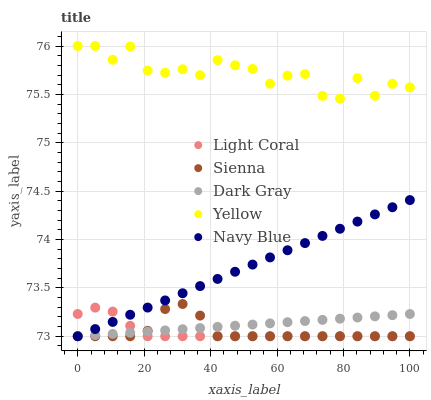Does Light Coral have the minimum area under the curve?
Answer yes or no. Yes. Does Yellow have the maximum area under the curve?
Answer yes or no. Yes. Does Sienna have the minimum area under the curve?
Answer yes or no. No. Does Sienna have the maximum area under the curve?
Answer yes or no. No. Is Navy Blue the smoothest?
Answer yes or no. Yes. Is Yellow the roughest?
Answer yes or no. Yes. Is Sienna the smoothest?
Answer yes or no. No. Is Sienna the roughest?
Answer yes or no. No. Does Light Coral have the lowest value?
Answer yes or no. Yes. Does Yellow have the lowest value?
Answer yes or no. No. Does Yellow have the highest value?
Answer yes or no. Yes. Does Sienna have the highest value?
Answer yes or no. No. Is Navy Blue less than Yellow?
Answer yes or no. Yes. Is Yellow greater than Light Coral?
Answer yes or no. Yes. Does Navy Blue intersect Dark Gray?
Answer yes or no. Yes. Is Navy Blue less than Dark Gray?
Answer yes or no. No. Is Navy Blue greater than Dark Gray?
Answer yes or no. No. Does Navy Blue intersect Yellow?
Answer yes or no. No. 